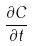<formula> <loc_0><loc_0><loc_500><loc_500>\frac { \partial C } { \partial t }</formula> 